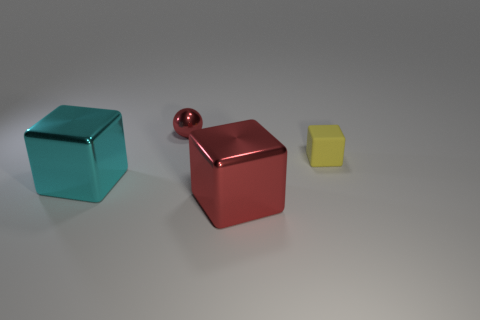Add 1 big red objects. How many objects exist? 5 Subtract all cyan shiny cubes. How many cubes are left? 2 Subtract all red blocks. Subtract all yellow objects. How many objects are left? 2 Add 2 large objects. How many large objects are left? 4 Add 2 matte objects. How many matte objects exist? 3 Subtract all red blocks. How many blocks are left? 2 Subtract 0 green balls. How many objects are left? 4 Subtract all blocks. How many objects are left? 1 Subtract all yellow blocks. Subtract all red spheres. How many blocks are left? 2 Subtract all red spheres. How many yellow blocks are left? 1 